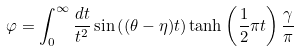<formula> <loc_0><loc_0><loc_500><loc_500>\varphi = \int _ { 0 } ^ { \infty } \frac { d t } { t ^ { 2 } } \sin \left ( ( \theta - \eta ) t \right ) \tanh \left ( \frac { 1 } { 2 } \pi t \right ) \frac { \gamma } { \pi }</formula> 